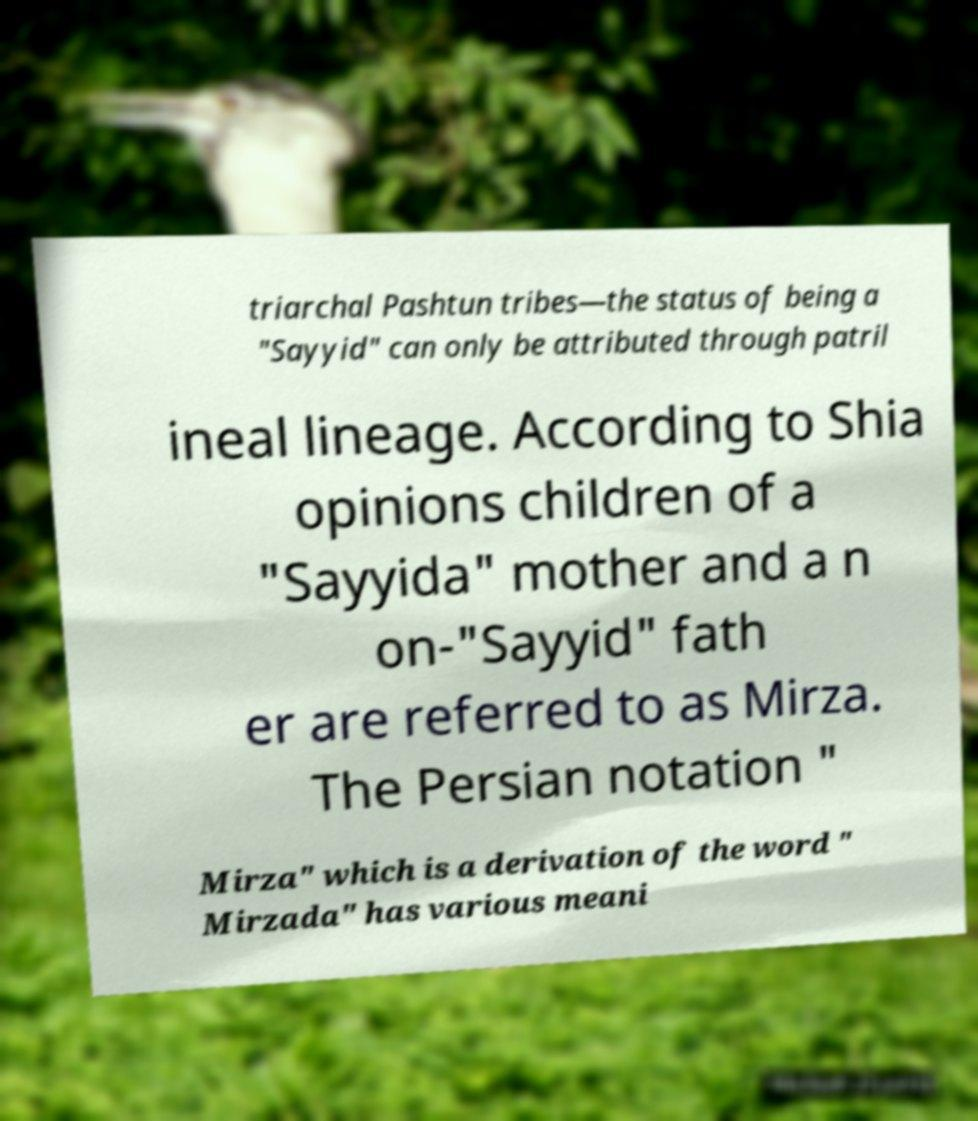Can you read and provide the text displayed in the image?This photo seems to have some interesting text. Can you extract and type it out for me? triarchal Pashtun tribes—the status of being a "Sayyid" can only be attributed through patril ineal lineage. According to Shia opinions children of a "Sayyida" mother and a n on-"Sayyid" fath er are referred to as Mirza. The Persian notation " Mirza" which is a derivation of the word " Mirzada" has various meani 